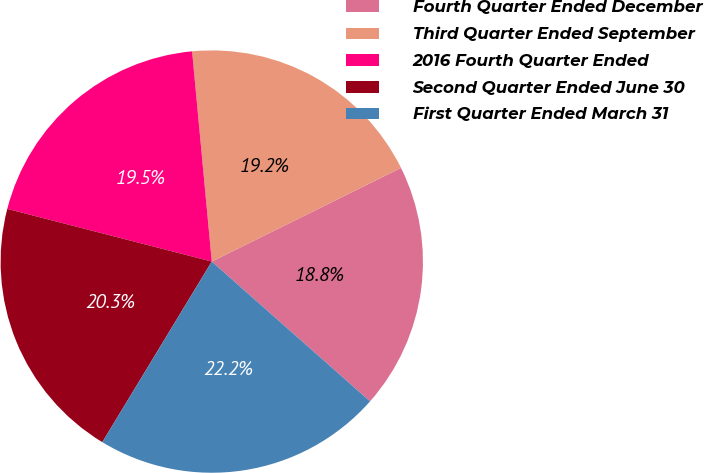<chart> <loc_0><loc_0><loc_500><loc_500><pie_chart><fcel>Fourth Quarter Ended December<fcel>Third Quarter Ended September<fcel>2016 Fourth Quarter Ended<fcel>Second Quarter Ended June 30<fcel>First Quarter Ended March 31<nl><fcel>18.83%<fcel>19.17%<fcel>19.5%<fcel>20.34%<fcel>22.16%<nl></chart> 